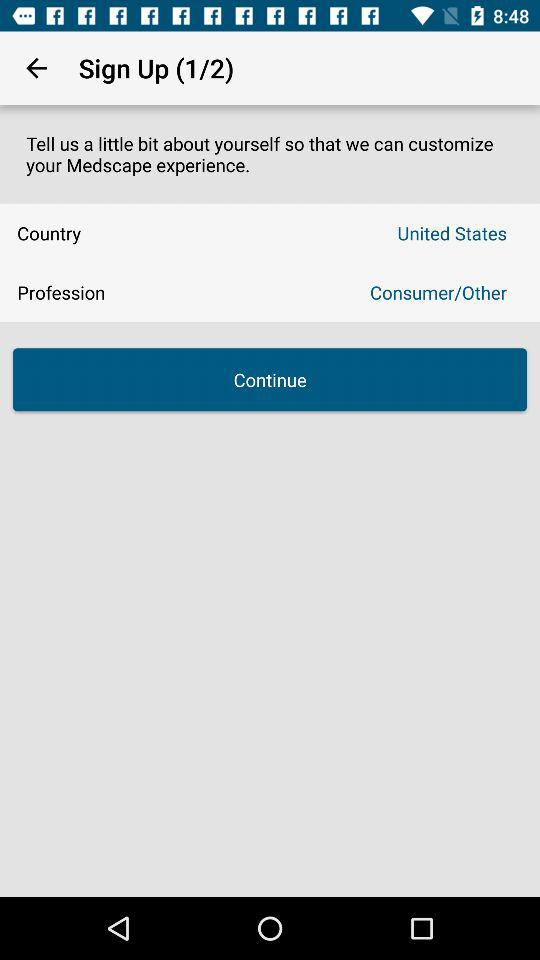How many steps are there in total to sign up? There are 2 steps in total to sign up. 